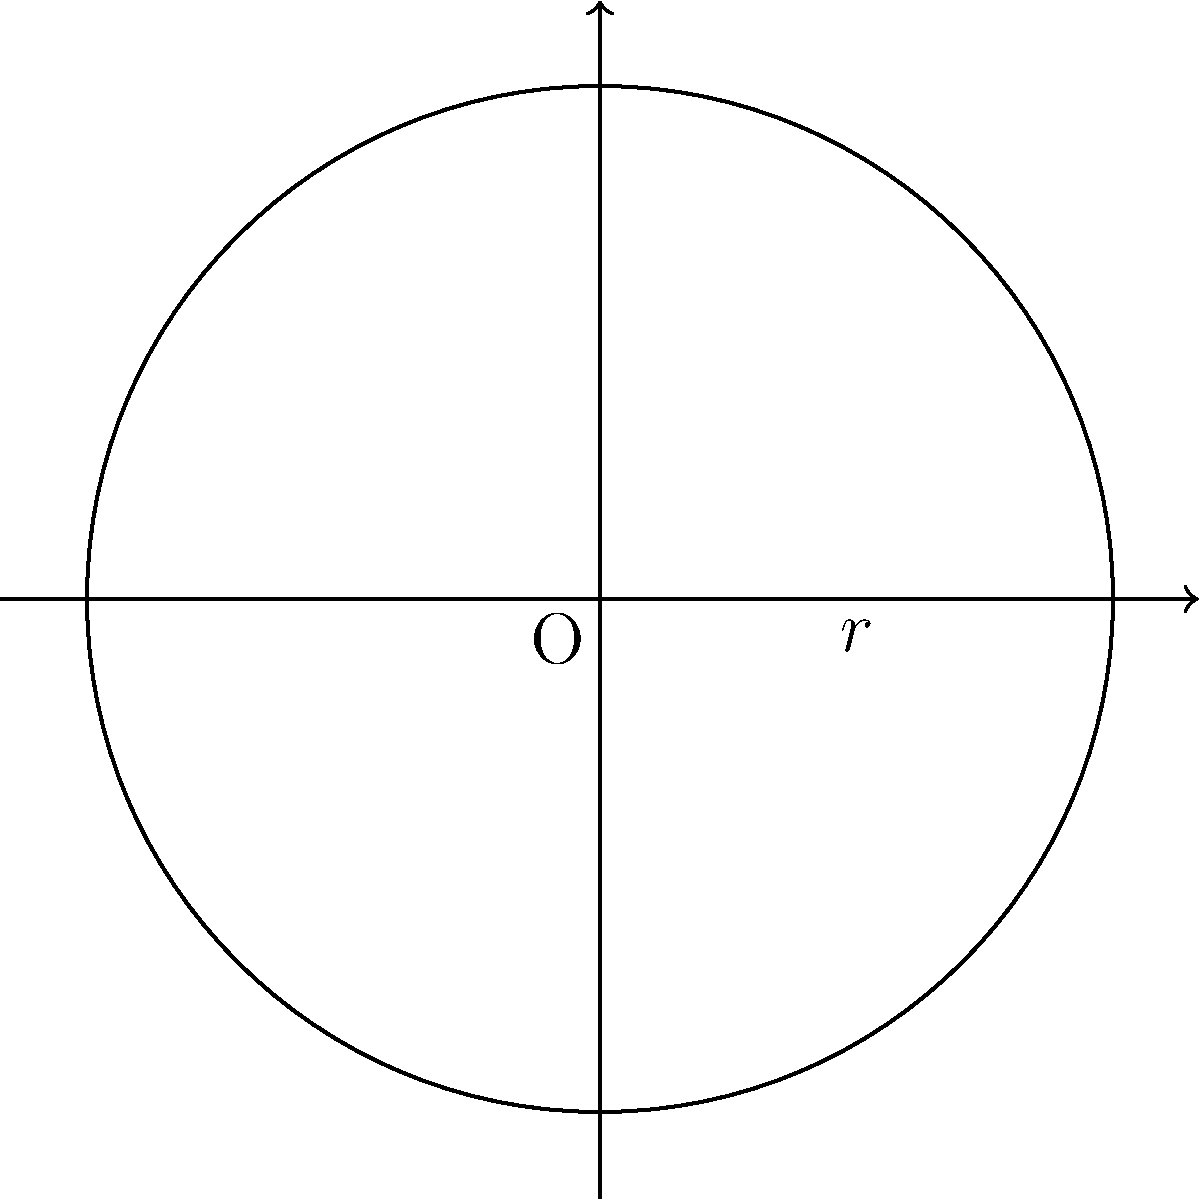In a training session, you're designing a circular penalty area for young talents to practice their shooting accuracy. If the radius of this circular area is 9.15 meters (matching the distance from the penalty spot to the edge of the penalty arc in official matches), what is the total area that the young players have to aim for? Let's approach this step-by-step:

1) We know that the radius ($r$) of the circular penalty area is 9.15 meters.

2) The formula for the area of a circle is $A = \pi r^2$, where $A$ is the area and $r$ is the radius.

3) Let's substitute our known value into the formula:
   $A = \pi (9.15)^2$

4) First, let's calculate $9.15^2$:
   $9.15^2 = 83.7225$

5) Now, let's multiply by $\pi$:
   $A = \pi (83.7225) \approx 263.0221$ square meters

6) Rounding to two decimal places for practical use:
   $A \approx 263.02$ square meters

This area represents the total space within which the young talents need to aim their shots during the training exercise.
Answer: $263.02 \text{ m}^2$ 